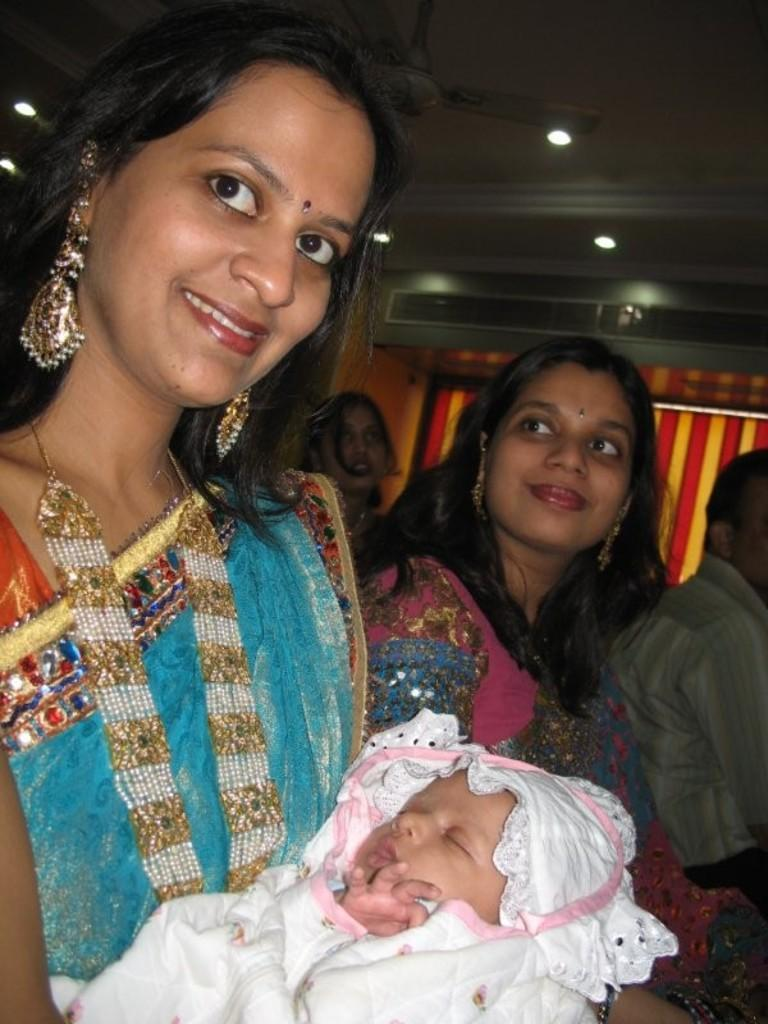How many people are in the image? There are three women and one man in the image. What is one of the women doing in the image? A woman in a blue saree is holding a baby. What type of appliance can be seen in the image? There is a fan in the image. What type of window treatment is present in the image? There is a curtain in the image. What type of lighting is present in the image? There are ceiling lights in the image. What type of property does the baby own in the image? The baby in the image is too young to own property. What type of pest can be seen in the image? There are no pests visible in the image. 